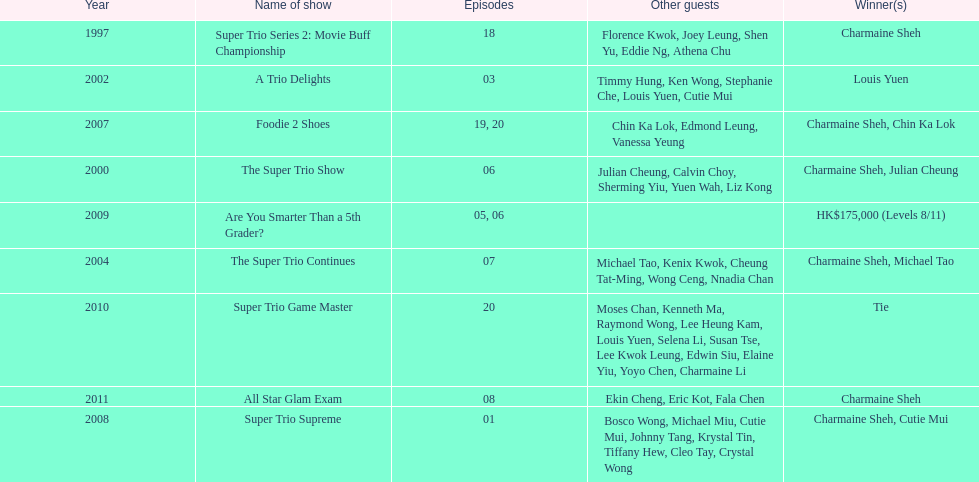How many consecutive trio shows did charmaine sheh do before being on another variety program? 34. 